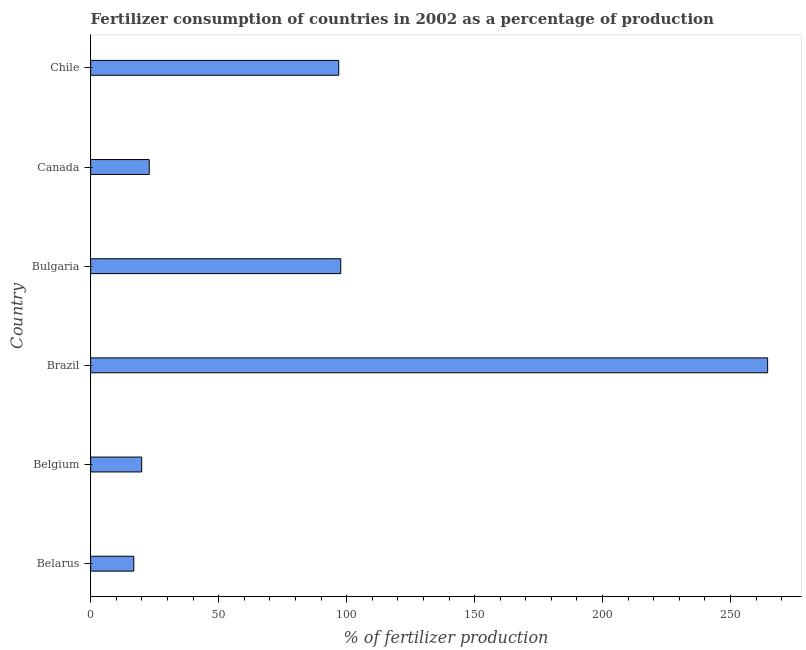Does the graph contain any zero values?
Provide a succinct answer. No. What is the title of the graph?
Provide a succinct answer. Fertilizer consumption of countries in 2002 as a percentage of production. What is the label or title of the X-axis?
Offer a terse response. % of fertilizer production. What is the amount of fertilizer consumption in Canada?
Your answer should be compact. 22.89. Across all countries, what is the maximum amount of fertilizer consumption?
Provide a succinct answer. 264.49. Across all countries, what is the minimum amount of fertilizer consumption?
Offer a terse response. 16.86. In which country was the amount of fertilizer consumption minimum?
Offer a very short reply. Belarus. What is the sum of the amount of fertilizer consumption?
Make the answer very short. 518.8. What is the difference between the amount of fertilizer consumption in Belgium and Bulgaria?
Ensure brevity in your answer.  -77.77. What is the average amount of fertilizer consumption per country?
Offer a terse response. 86.47. What is the median amount of fertilizer consumption?
Make the answer very short. 59.9. What is the ratio of the amount of fertilizer consumption in Belgium to that in Canada?
Give a very brief answer. 0.87. Is the difference between the amount of fertilizer consumption in Bulgaria and Canada greater than the difference between any two countries?
Make the answer very short. No. What is the difference between the highest and the second highest amount of fertilizer consumption?
Make the answer very short. 166.78. Is the sum of the amount of fertilizer consumption in Belgium and Brazil greater than the maximum amount of fertilizer consumption across all countries?
Provide a short and direct response. Yes. What is the difference between the highest and the lowest amount of fertilizer consumption?
Ensure brevity in your answer.  247.63. In how many countries, is the amount of fertilizer consumption greater than the average amount of fertilizer consumption taken over all countries?
Your answer should be very brief. 3. Are all the bars in the graph horizontal?
Provide a succinct answer. Yes. How many countries are there in the graph?
Your answer should be compact. 6. What is the % of fertilizer production in Belarus?
Provide a short and direct response. 16.86. What is the % of fertilizer production in Belgium?
Provide a short and direct response. 19.94. What is the % of fertilizer production of Brazil?
Your answer should be very brief. 264.49. What is the % of fertilizer production of Bulgaria?
Give a very brief answer. 97.71. What is the % of fertilizer production of Canada?
Provide a succinct answer. 22.89. What is the % of fertilizer production of Chile?
Ensure brevity in your answer.  96.91. What is the difference between the % of fertilizer production in Belarus and Belgium?
Make the answer very short. -3.08. What is the difference between the % of fertilizer production in Belarus and Brazil?
Give a very brief answer. -247.63. What is the difference between the % of fertilizer production in Belarus and Bulgaria?
Make the answer very short. -80.85. What is the difference between the % of fertilizer production in Belarus and Canada?
Provide a short and direct response. -6.03. What is the difference between the % of fertilizer production in Belarus and Chile?
Keep it short and to the point. -80.06. What is the difference between the % of fertilizer production in Belgium and Brazil?
Ensure brevity in your answer.  -244.55. What is the difference between the % of fertilizer production in Belgium and Bulgaria?
Provide a succinct answer. -77.77. What is the difference between the % of fertilizer production in Belgium and Canada?
Your answer should be very brief. -2.95. What is the difference between the % of fertilizer production in Belgium and Chile?
Keep it short and to the point. -76.97. What is the difference between the % of fertilizer production in Brazil and Bulgaria?
Make the answer very short. 166.78. What is the difference between the % of fertilizer production in Brazil and Canada?
Your answer should be compact. 241.6. What is the difference between the % of fertilizer production in Brazil and Chile?
Provide a short and direct response. 167.58. What is the difference between the % of fertilizer production in Bulgaria and Canada?
Give a very brief answer. 74.82. What is the difference between the % of fertilizer production in Bulgaria and Chile?
Make the answer very short. 0.8. What is the difference between the % of fertilizer production in Canada and Chile?
Offer a very short reply. -74.03. What is the ratio of the % of fertilizer production in Belarus to that in Belgium?
Provide a short and direct response. 0.84. What is the ratio of the % of fertilizer production in Belarus to that in Brazil?
Your response must be concise. 0.06. What is the ratio of the % of fertilizer production in Belarus to that in Bulgaria?
Your response must be concise. 0.17. What is the ratio of the % of fertilizer production in Belarus to that in Canada?
Offer a terse response. 0.74. What is the ratio of the % of fertilizer production in Belarus to that in Chile?
Your response must be concise. 0.17. What is the ratio of the % of fertilizer production in Belgium to that in Brazil?
Make the answer very short. 0.07. What is the ratio of the % of fertilizer production in Belgium to that in Bulgaria?
Offer a very short reply. 0.2. What is the ratio of the % of fertilizer production in Belgium to that in Canada?
Provide a short and direct response. 0.87. What is the ratio of the % of fertilizer production in Belgium to that in Chile?
Make the answer very short. 0.21. What is the ratio of the % of fertilizer production in Brazil to that in Bulgaria?
Offer a terse response. 2.71. What is the ratio of the % of fertilizer production in Brazil to that in Canada?
Your answer should be compact. 11.56. What is the ratio of the % of fertilizer production in Brazil to that in Chile?
Provide a short and direct response. 2.73. What is the ratio of the % of fertilizer production in Bulgaria to that in Canada?
Keep it short and to the point. 4.27. What is the ratio of the % of fertilizer production in Canada to that in Chile?
Offer a terse response. 0.24. 